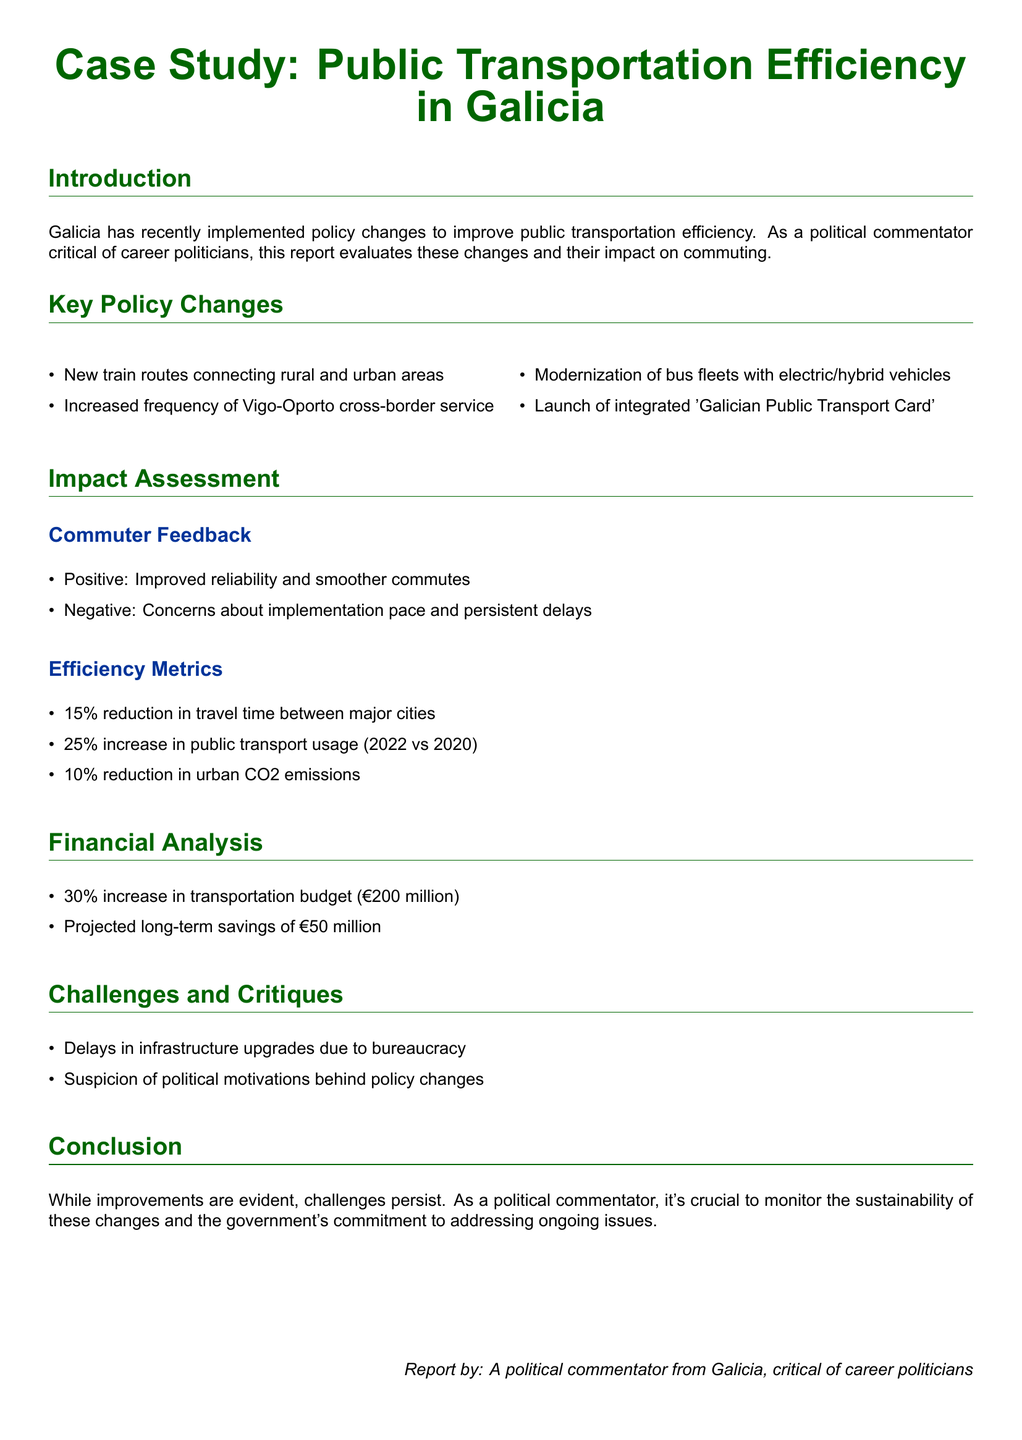What are the new train routes for? The new train routes aim to connect rural and urban areas to improve transportation efficiency.
Answer: rural and urban areas What is the increase in public transport usage from 2020 to 2022? The report states that there was a 25% increase in public transport usage in the indicated period.
Answer: 25% What is the budget increase for transportation? The report mentions a 30% increase in the transportation budget, amounting to €200 million.
Answer: €200 million What are the environmental benefits noted in the report? The report highlights a 10% reduction in urban CO2 emissions as a positive environmental impact.
Answer: 10% What is a major challenge faced in infrastructure upgrades? Delays in infrastructure upgrades are primarily attributed to bureaucracy, as stated in the report.
Answer: bureaucracy What does the Galician Public Transport Card aim to achieve? The launch of the integrated 'Galician Public Transport Card' aims to enhance the efficiency of public transportation.
Answer: efficiency What long-term savings are projected from the transportation policy changes? The projected long-term savings from the changes are estimated to be €50 million.
Answer: €50 million What feedback did commuters have about reliability? Commuters reported improved reliability in their commutes as a positive feedback.
Answer: reliability What suspicion surrounds the policy changes? There is a suspicion regarding political motivations behind the proposed policy changes, as noted in the report.
Answer: political motivations 